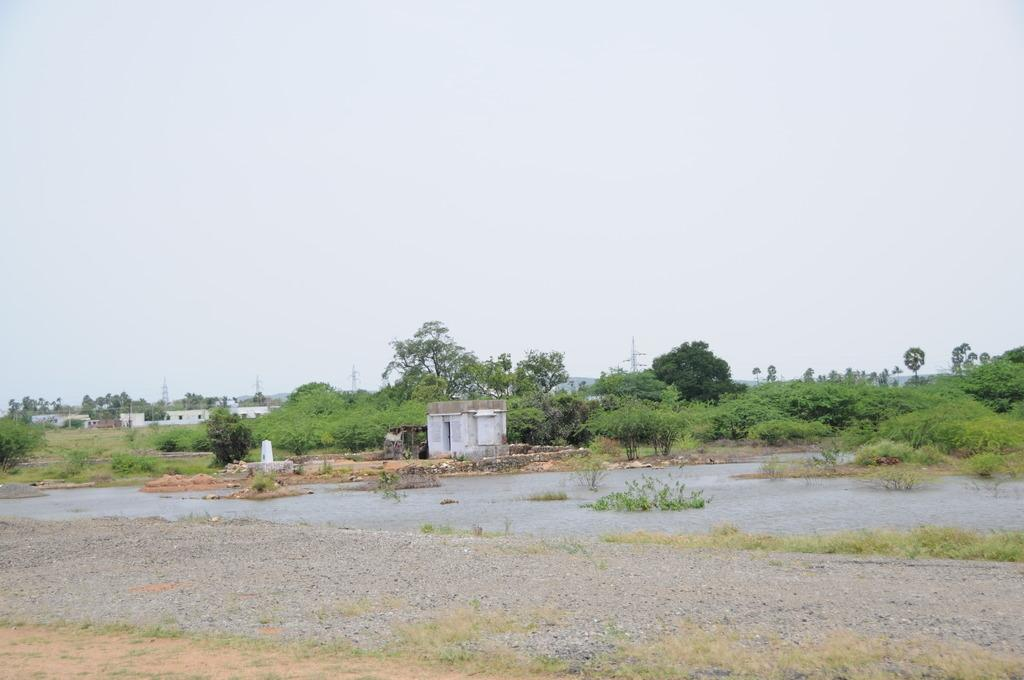What type of vegetation can be seen in the image? There are trees in the image. What structures are present in the image? There are poles and houses in the image. What is visible at the top of the image? The sky is visible at the top of the image. What is present at the bottom of the image? There is water and ground at the bottom of the image. Can you recite the verse that is written on the trees in the image? There is no verse written on the trees in the image; they are simply trees. How fast do the bubbles move in the water at the bottom of the image? There are no bubbles present in the image; it features trees, poles, houses, sky, water, and ground. 